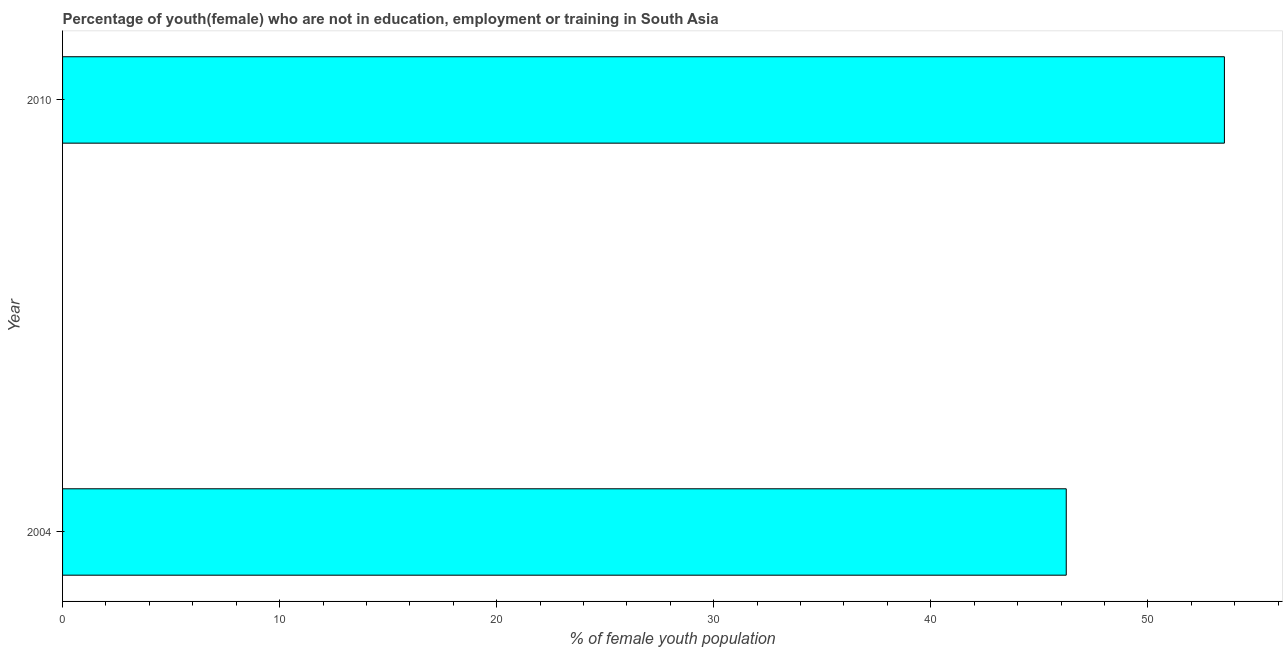Does the graph contain any zero values?
Your answer should be very brief. No. Does the graph contain grids?
Offer a terse response. No. What is the title of the graph?
Your answer should be very brief. Percentage of youth(female) who are not in education, employment or training in South Asia. What is the label or title of the X-axis?
Give a very brief answer. % of female youth population. What is the label or title of the Y-axis?
Make the answer very short. Year. What is the unemployed female youth population in 2004?
Offer a terse response. 46.24. Across all years, what is the maximum unemployed female youth population?
Offer a very short reply. 53.53. Across all years, what is the minimum unemployed female youth population?
Offer a very short reply. 46.24. In which year was the unemployed female youth population minimum?
Provide a succinct answer. 2004. What is the sum of the unemployed female youth population?
Your answer should be very brief. 99.77. What is the difference between the unemployed female youth population in 2004 and 2010?
Give a very brief answer. -7.29. What is the average unemployed female youth population per year?
Your answer should be compact. 49.88. What is the median unemployed female youth population?
Provide a short and direct response. 49.88. In how many years, is the unemployed female youth population greater than 34 %?
Make the answer very short. 2. Do a majority of the years between 2010 and 2004 (inclusive) have unemployed female youth population greater than 10 %?
Offer a terse response. No. What is the ratio of the unemployed female youth population in 2004 to that in 2010?
Provide a succinct answer. 0.86. What is the difference between two consecutive major ticks on the X-axis?
Give a very brief answer. 10. What is the % of female youth population in 2004?
Make the answer very short. 46.24. What is the % of female youth population in 2010?
Make the answer very short. 53.53. What is the difference between the % of female youth population in 2004 and 2010?
Your response must be concise. -7.29. What is the ratio of the % of female youth population in 2004 to that in 2010?
Your answer should be compact. 0.86. 